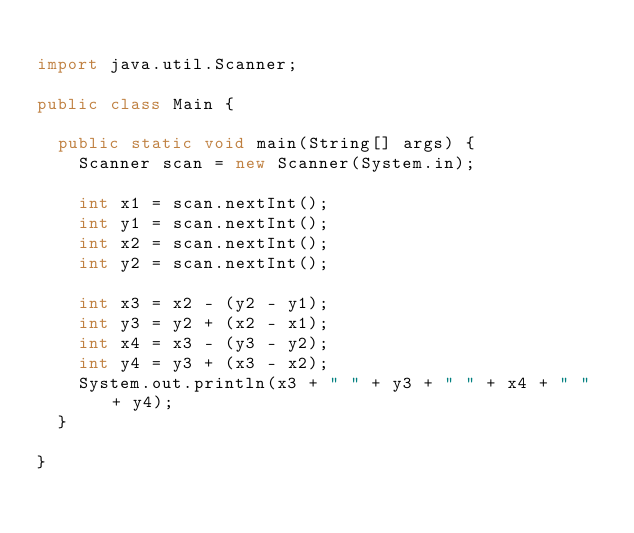Convert code to text. <code><loc_0><loc_0><loc_500><loc_500><_Java_>
import java.util.Scanner;

public class Main {

	public static void main(String[] args) {
		Scanner scan = new Scanner(System.in);

		int x1 = scan.nextInt();
		int y1 = scan.nextInt();
		int x2 = scan.nextInt();
		int y2 = scan.nextInt();

		int x3 = x2 - (y2 - y1);
		int y3 = y2 + (x2 - x1);
		int x4 = x3 - (y3 - y2);
		int y4 = y3 + (x3 - x2);
		System.out.println(x3 + " " + y3 + " " + x4 + " " + y4);
	}

}
</code> 